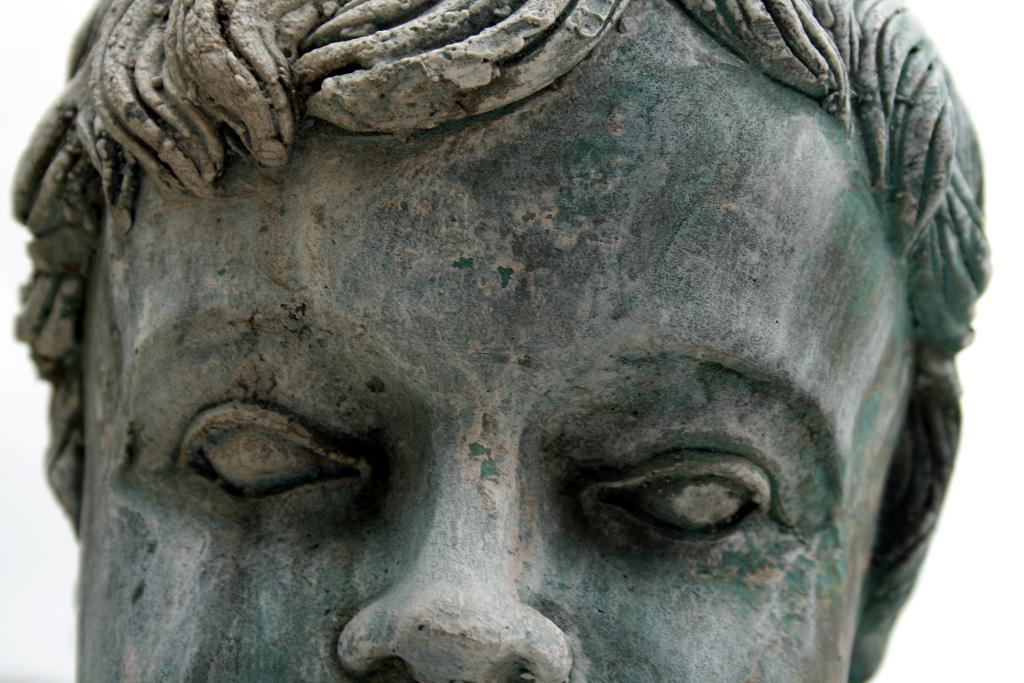What is the main subject of the image? There is a statue in the image. Can you describe the statue? The statue is of a person. How many letters are on the card held by the person in the statue? There is no card or letters present in the image, as the statue is of a person and not holding any cards. 